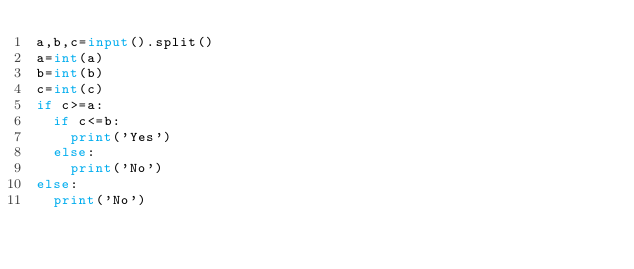Convert code to text. <code><loc_0><loc_0><loc_500><loc_500><_Python_>a,b,c=input().split()
a=int(a)
b=int(b)
c=int(c)
if c>=a:
  if c<=b:
    print('Yes')
  else:
    print('No')
else:
  print('No')</code> 